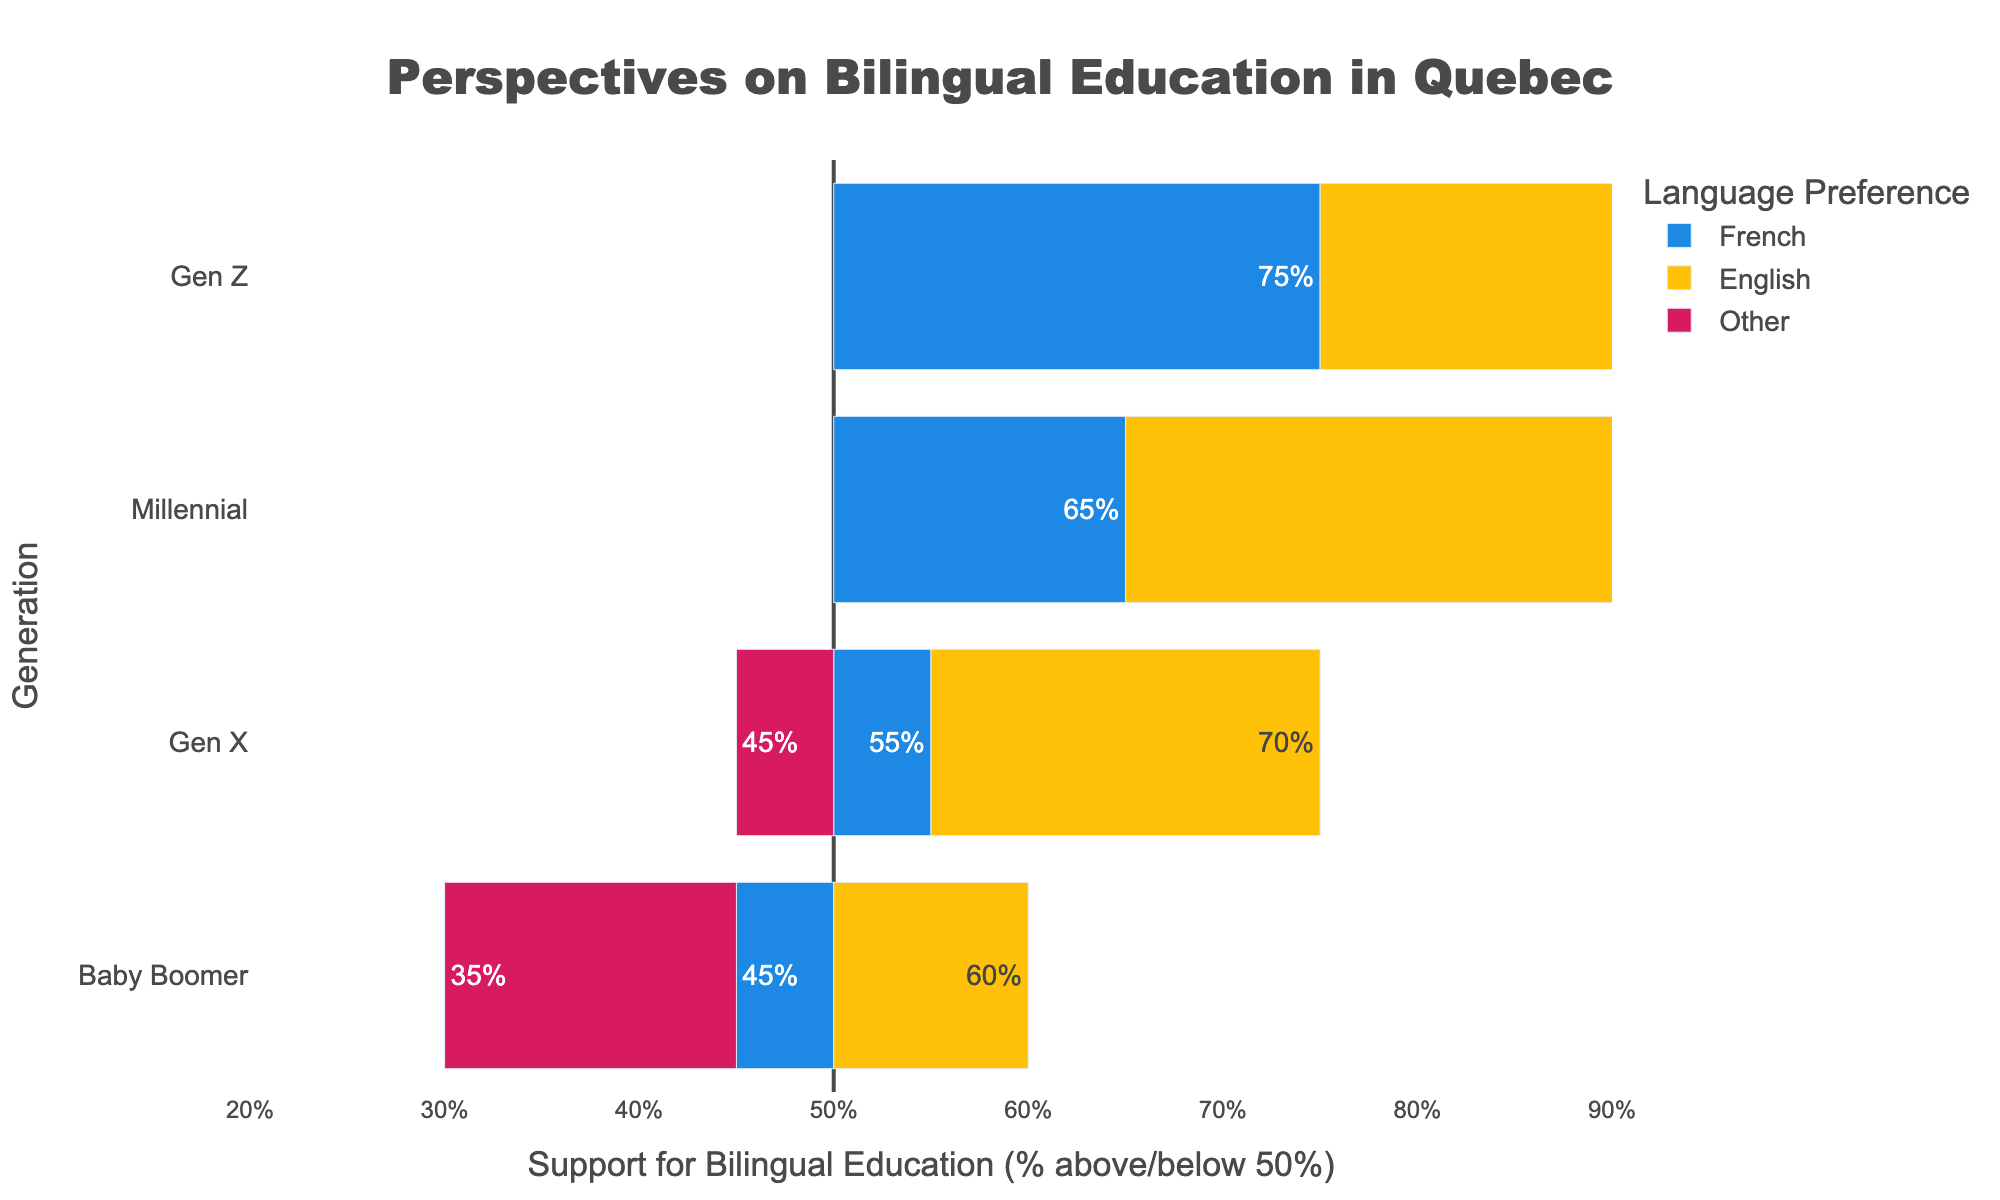How does the support for bilingual education among Gen Z compare between French and English language preferences? The support for bilingual education among Gen Z for French is 75%, and for English, it is 85%. Subtract the former from the latter: 85 - 75 = 10%.
Answer: 10% Which generation shows the smallest difference in support for bilingual education between French and English language preferences? Compare the differences for each generation: 
- Gen Z: 85% - 75% = 10%
- Millennial: 80% - 65% = 15%
- Gen X: 70% - 55% = 15%
- Baby Boomer: 60% - 45% = 15%. 
The smallest difference is for Gen Z.
Answer: Gen Z What is the total support percentage for bilingual education across all generations for French language preference? Add the support percentages for all generations for French: 75% (Gen Z) + 65% (Millennial) + 55% (Gen X) + 45% (Baby Boomer) = 240%.
Answer: 240% What is the difference in support for bilingual education between the youngest and the oldest generation for the 'Other' language preference group? The support for Gen Z is 60% and for Baby Boomer it is 35%. Subtract the latter from the former: 60% - 35% = 25%.
Answer: 25% Which group has the highest overall support for bilingual education, and what is the percentage? From the data, English-speaking Gen Z has the highest support at 85%.
Answer: English Gen Z, 85% How do the visual lengths of the bars for French and Other preferences among Millennials indicate differences in support for bilingual education? For Millennials, the French bar (65%) is longer compared to the bar for Other preferences (50%). The visual difference corresponds to a 65% - 50% = 15% difference.
Answer: 15% What is the average support for bilingual education across all generations for English language preference? Add the support percentages for all generations for English and divide by the number of generations: (85% + 80% + 70% + 60%) / 4 = 73.75%.
Answer: 73.75% How does the average support for bilingual education for Millennials compare between French and English language preferences? Calculate the average for both groups: French Millennials (65%), English Millennials (80%). The difference is 80% - 65% = 15%.
Answer: 15% Among which language group is the support for bilingual education the lowest for all generations? By observing all the bars, the "Other" language preference group has the lowest support percentages: 60% (Gen Z), 50% (Millennial), 45% (Gen X), 35% (Baby Boomer).
Answer: Other What is the combined support for bilingual education in Gen Z for all language preferences? Add the support percentages for Gen Z across all language preferences: 75% (French) + 85% (English) + 60% (Other) = 220%.
Answer: 220% 